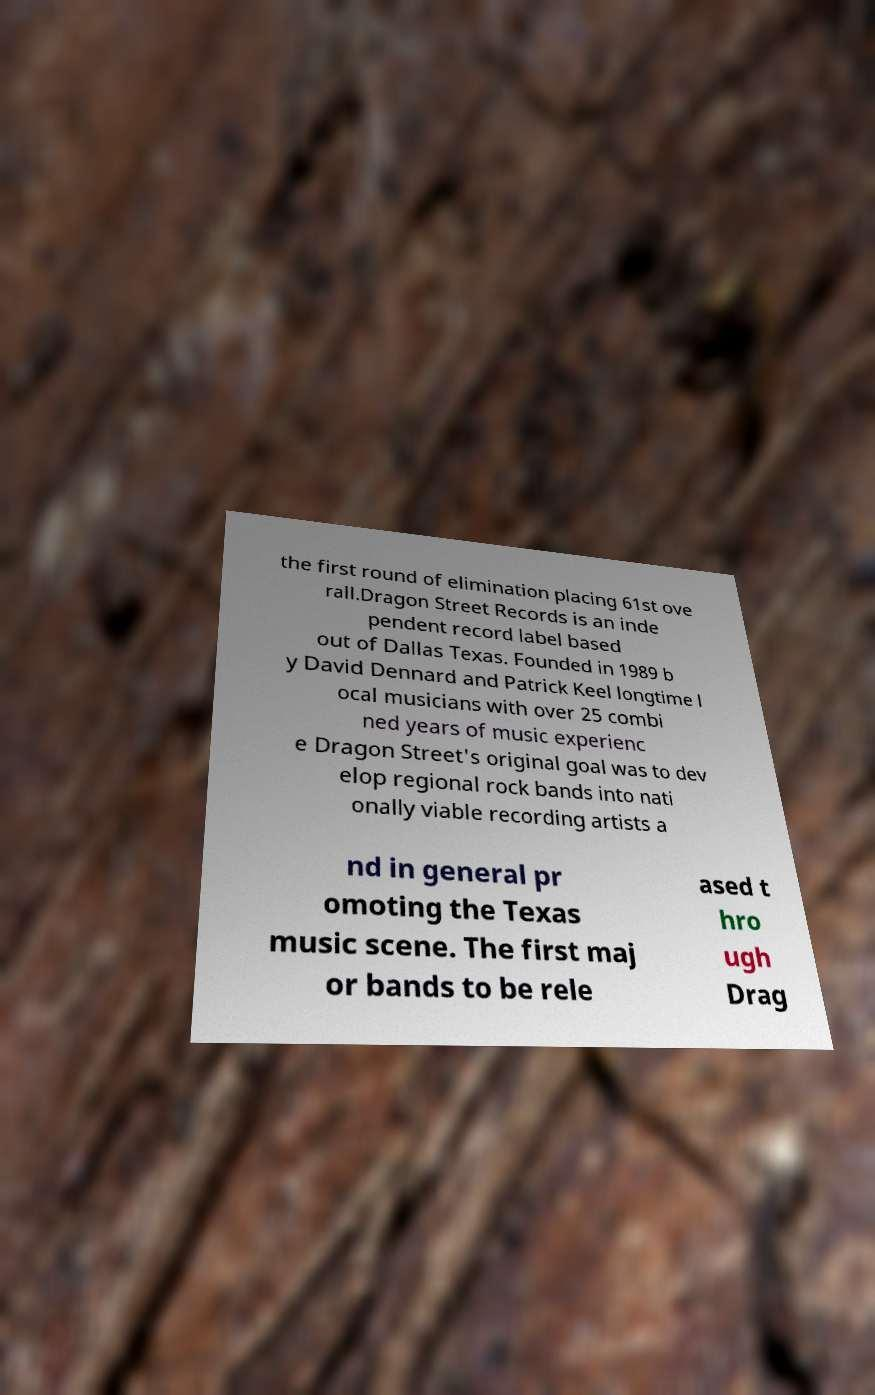Can you accurately transcribe the text from the provided image for me? the first round of elimination placing 61st ove rall.Dragon Street Records is an inde pendent record label based out of Dallas Texas. Founded in 1989 b y David Dennard and Patrick Keel longtime l ocal musicians with over 25 combi ned years of music experienc e Dragon Street's original goal was to dev elop regional rock bands into nati onally viable recording artists a nd in general pr omoting the Texas music scene. The first maj or bands to be rele ased t hro ugh Drag 